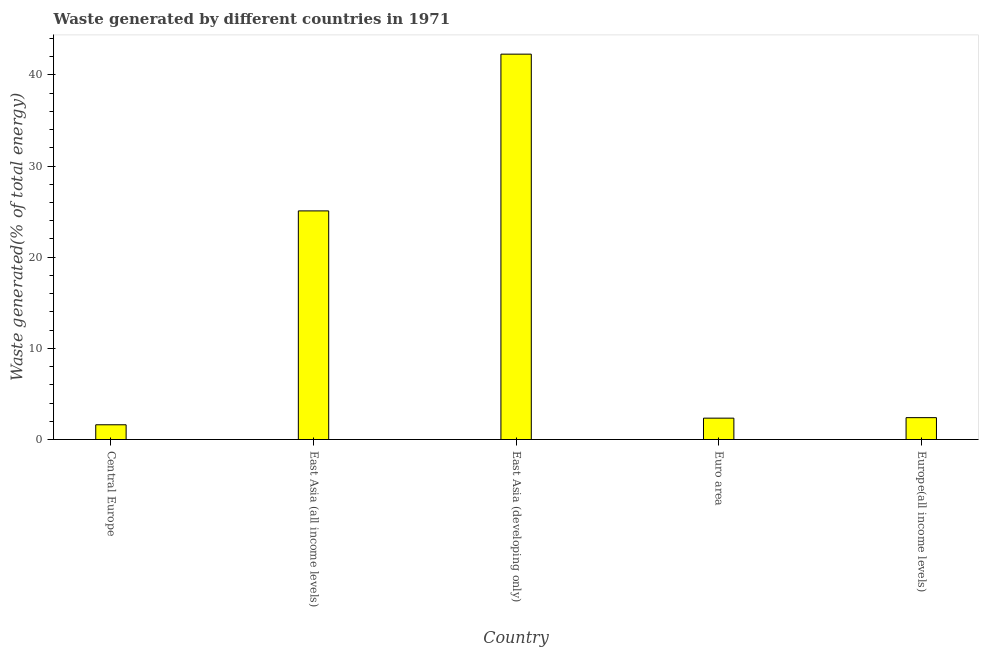Does the graph contain any zero values?
Provide a succinct answer. No. Does the graph contain grids?
Your response must be concise. No. What is the title of the graph?
Offer a terse response. Waste generated by different countries in 1971. What is the label or title of the X-axis?
Offer a terse response. Country. What is the label or title of the Y-axis?
Your response must be concise. Waste generated(% of total energy). What is the amount of waste generated in Central Europe?
Provide a short and direct response. 1.62. Across all countries, what is the maximum amount of waste generated?
Keep it short and to the point. 42.27. Across all countries, what is the minimum amount of waste generated?
Provide a short and direct response. 1.62. In which country was the amount of waste generated maximum?
Provide a succinct answer. East Asia (developing only). In which country was the amount of waste generated minimum?
Make the answer very short. Central Europe. What is the sum of the amount of waste generated?
Make the answer very short. 73.7. What is the difference between the amount of waste generated in East Asia (all income levels) and Europe(all income levels)?
Ensure brevity in your answer.  22.68. What is the average amount of waste generated per country?
Make the answer very short. 14.74. What is the median amount of waste generated?
Make the answer very short. 2.4. What is the ratio of the amount of waste generated in Central Europe to that in East Asia (all income levels)?
Offer a terse response. 0.07. What is the difference between the highest and the second highest amount of waste generated?
Offer a terse response. 17.19. Is the sum of the amount of waste generated in Central Europe and East Asia (all income levels) greater than the maximum amount of waste generated across all countries?
Your answer should be compact. No. What is the difference between the highest and the lowest amount of waste generated?
Make the answer very short. 40.65. In how many countries, is the amount of waste generated greater than the average amount of waste generated taken over all countries?
Offer a terse response. 2. How many bars are there?
Give a very brief answer. 5. Are all the bars in the graph horizontal?
Offer a terse response. No. What is the Waste generated(% of total energy) in Central Europe?
Make the answer very short. 1.62. What is the Waste generated(% of total energy) of East Asia (all income levels)?
Your response must be concise. 25.07. What is the Waste generated(% of total energy) of East Asia (developing only)?
Make the answer very short. 42.27. What is the Waste generated(% of total energy) in Euro area?
Your answer should be very brief. 2.34. What is the Waste generated(% of total energy) in Europe(all income levels)?
Your response must be concise. 2.4. What is the difference between the Waste generated(% of total energy) in Central Europe and East Asia (all income levels)?
Make the answer very short. -23.46. What is the difference between the Waste generated(% of total energy) in Central Europe and East Asia (developing only)?
Your answer should be compact. -40.65. What is the difference between the Waste generated(% of total energy) in Central Europe and Euro area?
Provide a succinct answer. -0.73. What is the difference between the Waste generated(% of total energy) in Central Europe and Europe(all income levels)?
Provide a short and direct response. -0.78. What is the difference between the Waste generated(% of total energy) in East Asia (all income levels) and East Asia (developing only)?
Provide a short and direct response. -17.19. What is the difference between the Waste generated(% of total energy) in East Asia (all income levels) and Euro area?
Give a very brief answer. 22.73. What is the difference between the Waste generated(% of total energy) in East Asia (all income levels) and Europe(all income levels)?
Provide a succinct answer. 22.68. What is the difference between the Waste generated(% of total energy) in East Asia (developing only) and Euro area?
Keep it short and to the point. 39.92. What is the difference between the Waste generated(% of total energy) in East Asia (developing only) and Europe(all income levels)?
Make the answer very short. 39.87. What is the difference between the Waste generated(% of total energy) in Euro area and Europe(all income levels)?
Ensure brevity in your answer.  -0.06. What is the ratio of the Waste generated(% of total energy) in Central Europe to that in East Asia (all income levels)?
Make the answer very short. 0.07. What is the ratio of the Waste generated(% of total energy) in Central Europe to that in East Asia (developing only)?
Your response must be concise. 0.04. What is the ratio of the Waste generated(% of total energy) in Central Europe to that in Euro area?
Your answer should be compact. 0.69. What is the ratio of the Waste generated(% of total energy) in Central Europe to that in Europe(all income levels)?
Keep it short and to the point. 0.67. What is the ratio of the Waste generated(% of total energy) in East Asia (all income levels) to that in East Asia (developing only)?
Provide a succinct answer. 0.59. What is the ratio of the Waste generated(% of total energy) in East Asia (all income levels) to that in Euro area?
Keep it short and to the point. 10.7. What is the ratio of the Waste generated(% of total energy) in East Asia (all income levels) to that in Europe(all income levels)?
Keep it short and to the point. 10.45. What is the ratio of the Waste generated(% of total energy) in East Asia (developing only) to that in Euro area?
Keep it short and to the point. 18.03. What is the ratio of the Waste generated(% of total energy) in East Asia (developing only) to that in Europe(all income levels)?
Offer a terse response. 17.62. 